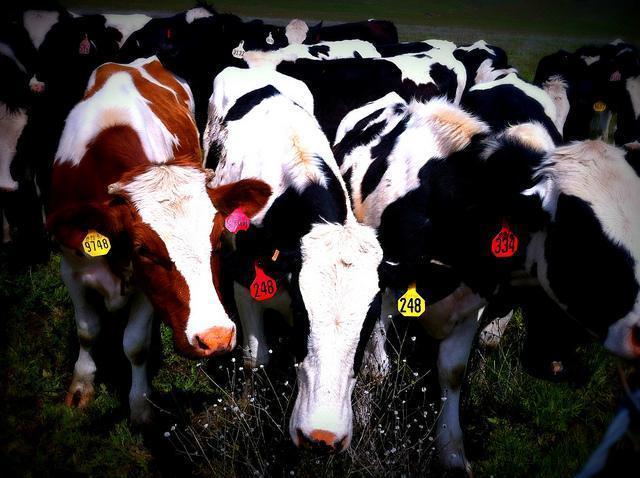How many tags do you see?
Give a very brief answer. 5. How many different colors of tags are there?
Give a very brief answer. 2. How many cows are there?
Give a very brief answer. 10. How many rings is the man wearing?
Give a very brief answer. 0. 